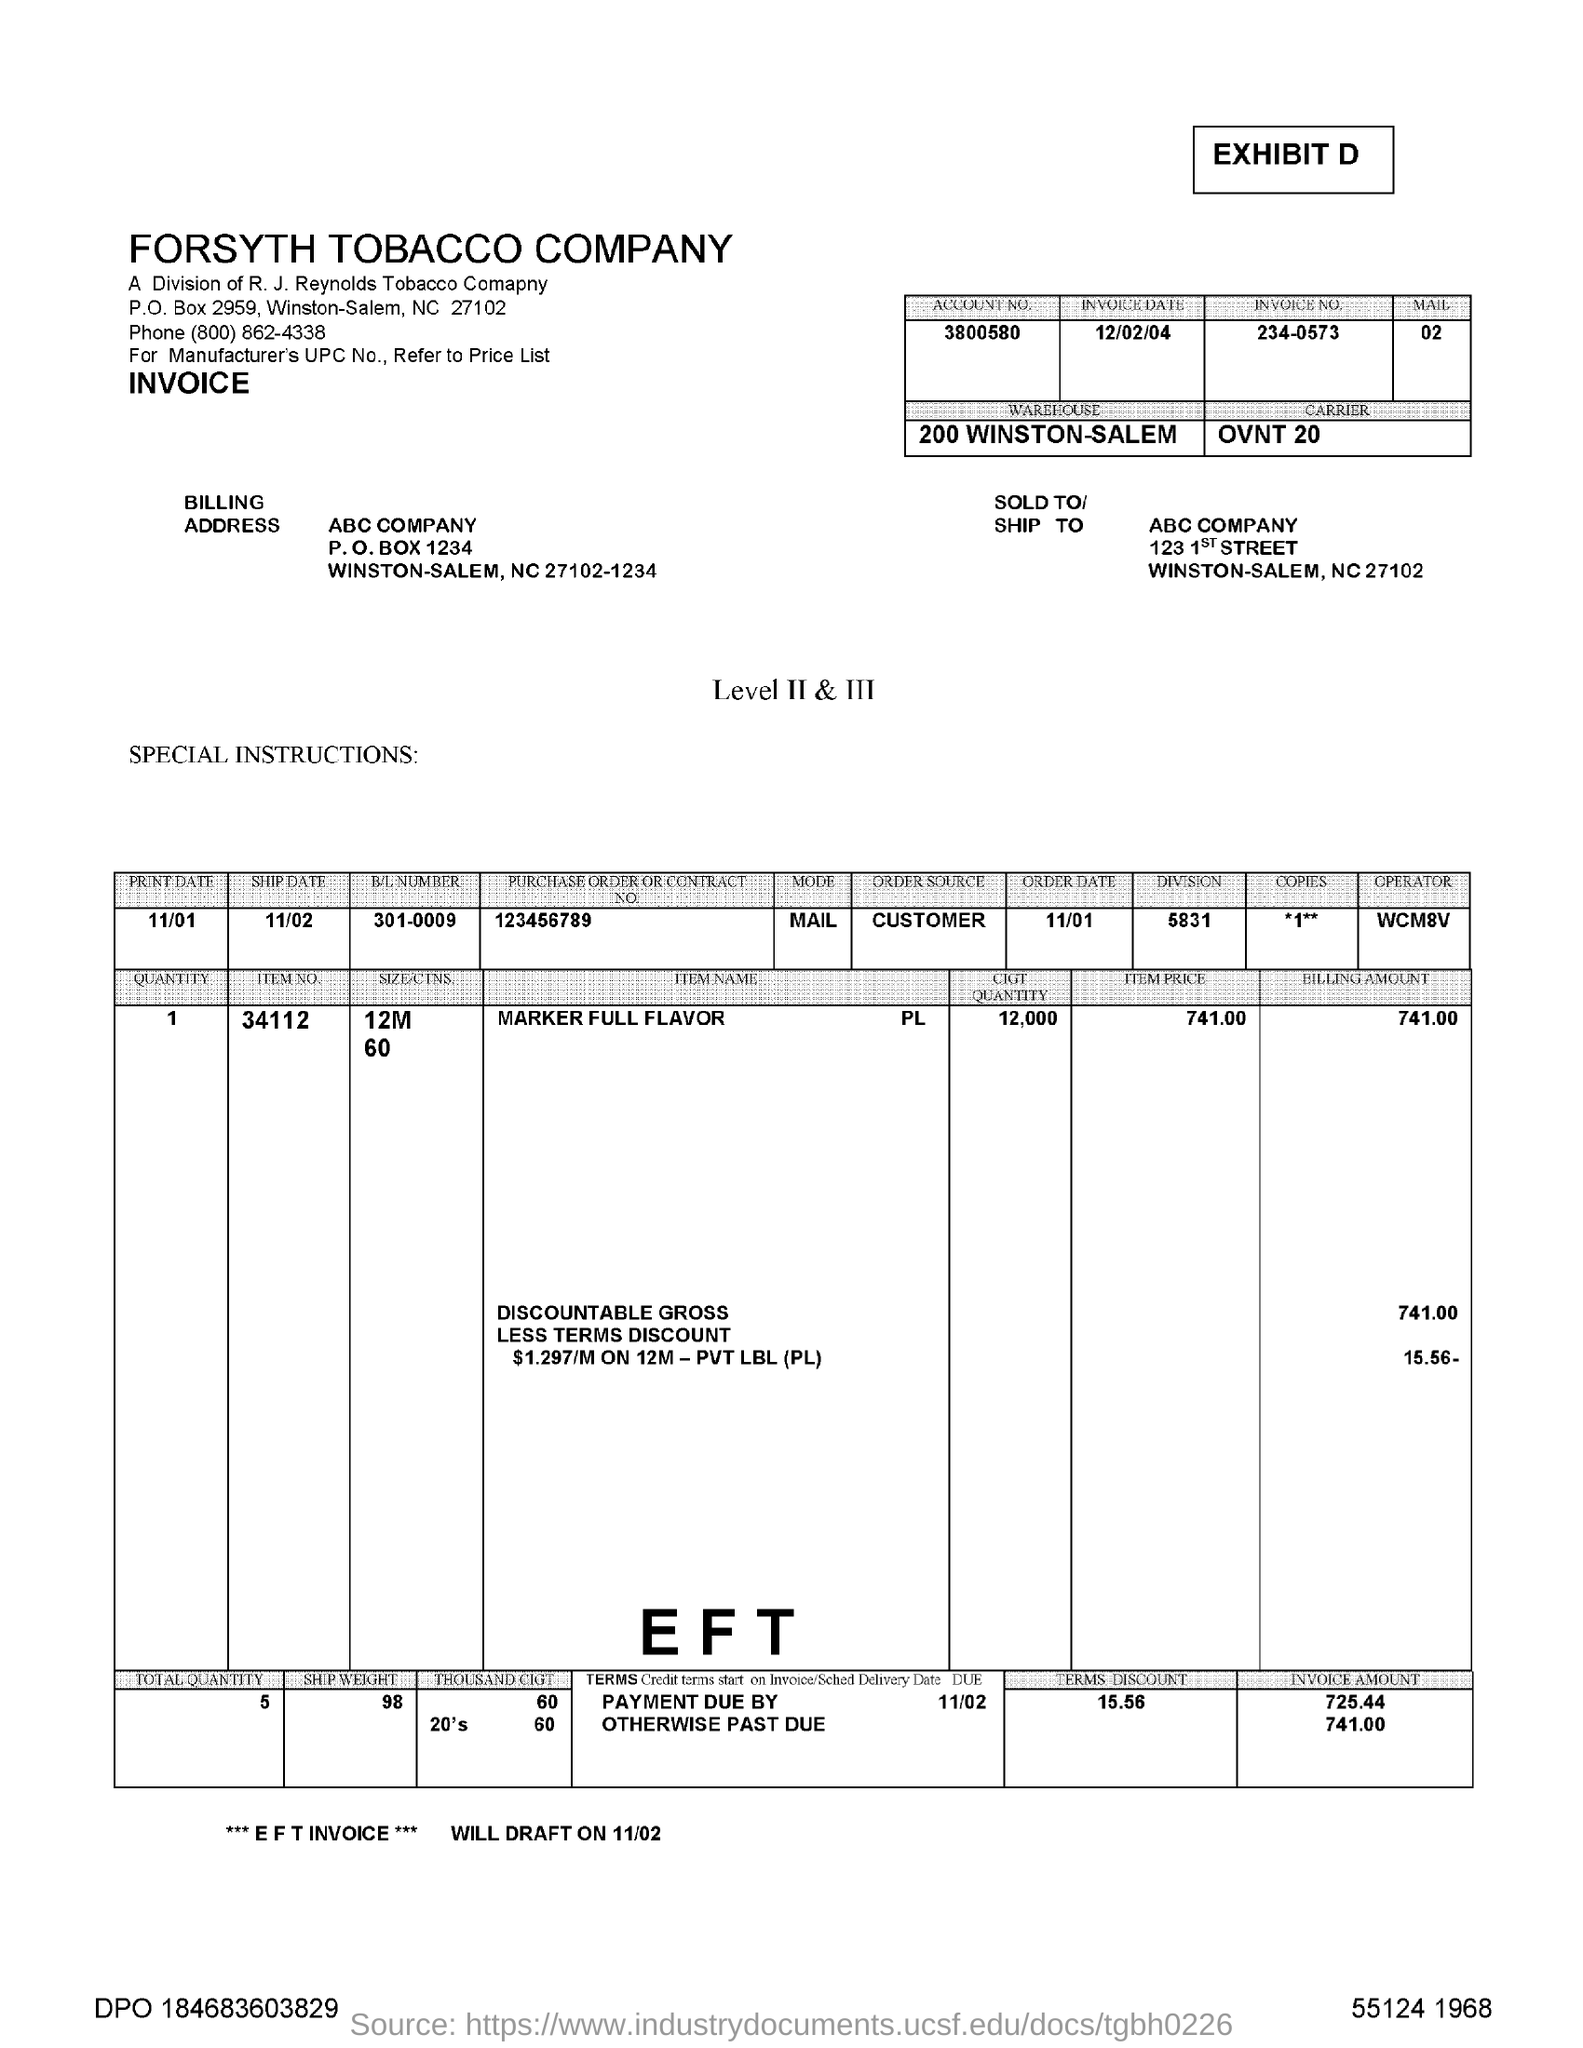Draw attention to some important aspects in this diagram. The "INVOICE DATE" refers to December 2, 2004. The "TERMS DISCOUNT" costs 15.56. The 'ITEM NO.' in the table is 34112. What is the P.O. Box number in the Billing Address? What is the account number given as? It is 3800580... 